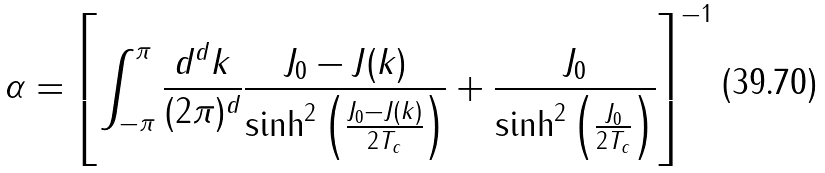<formula> <loc_0><loc_0><loc_500><loc_500>\alpha = \left [ \int _ { - \pi } ^ { \pi } \frac { d ^ { d } { k } } { ( 2 \pi ) ^ { d } } \frac { J _ { 0 } - J ( { k } ) } { \sinh ^ { 2 } \left ( \frac { J _ { 0 } - J ( { k } ) } { 2 T _ { c } } \right ) } + \frac { J _ { 0 } } { \sinh ^ { 2 } \left ( \frac { J _ { 0 } } { 2 T _ { c } } \right ) } \right ] ^ { - 1 }</formula> 